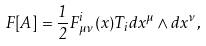<formula> <loc_0><loc_0><loc_500><loc_500>F [ A ] = \frac { 1 } { 2 } F _ { \mu \nu } ^ { i } ( x ) T _ { i } d x ^ { \mu } \wedge d x ^ { \nu } ,</formula> 